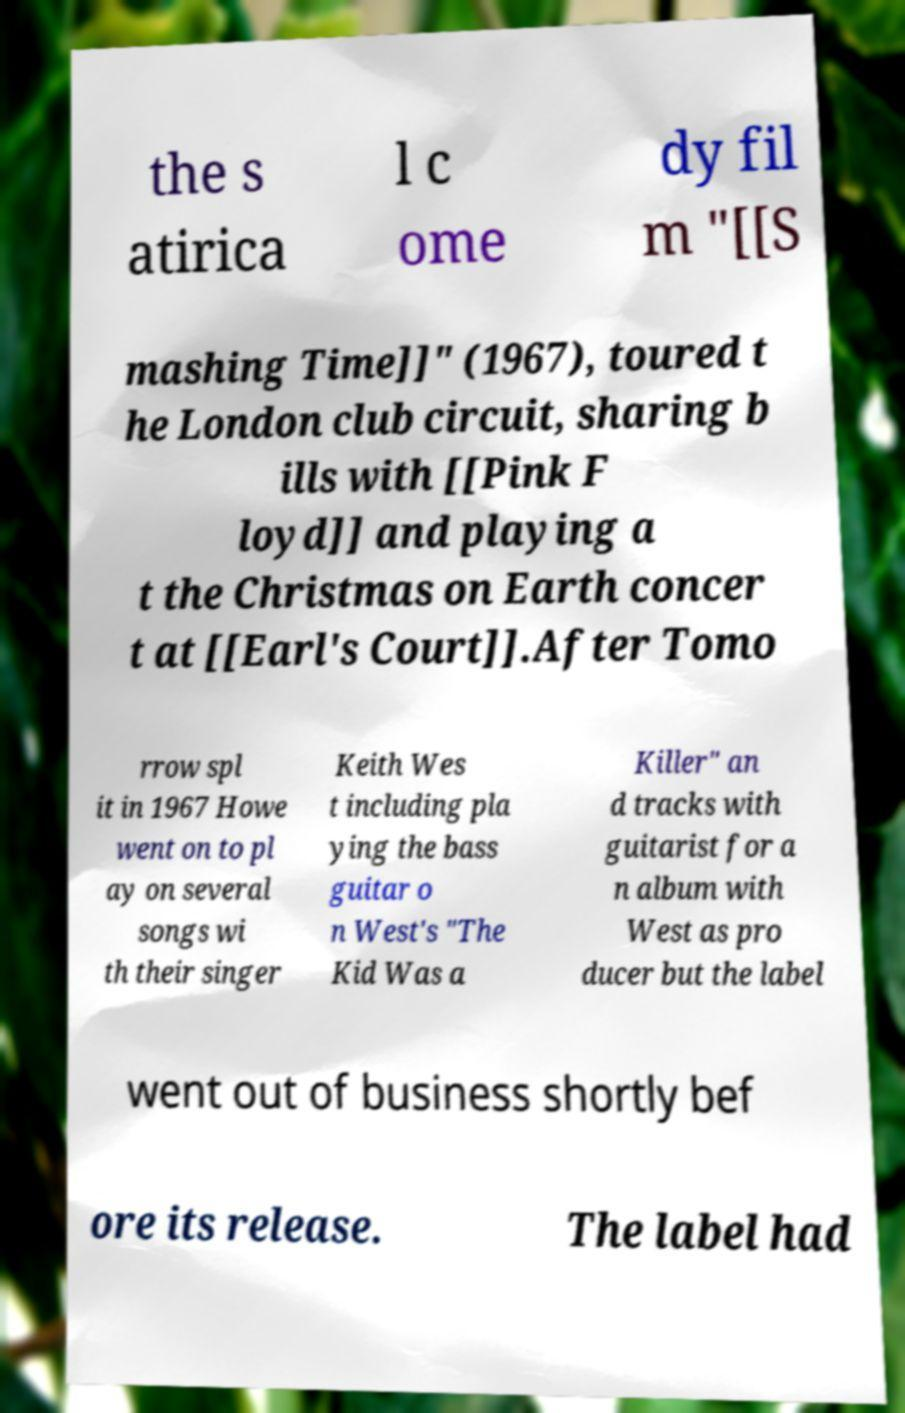Can you read and provide the text displayed in the image?This photo seems to have some interesting text. Can you extract and type it out for me? the s atirica l c ome dy fil m "[[S mashing Time]]" (1967), toured t he London club circuit, sharing b ills with [[Pink F loyd]] and playing a t the Christmas on Earth concer t at [[Earl's Court]].After Tomo rrow spl it in 1967 Howe went on to pl ay on several songs wi th their singer Keith Wes t including pla ying the bass guitar o n West's "The Kid Was a Killer" an d tracks with guitarist for a n album with West as pro ducer but the label went out of business shortly bef ore its release. The label had 